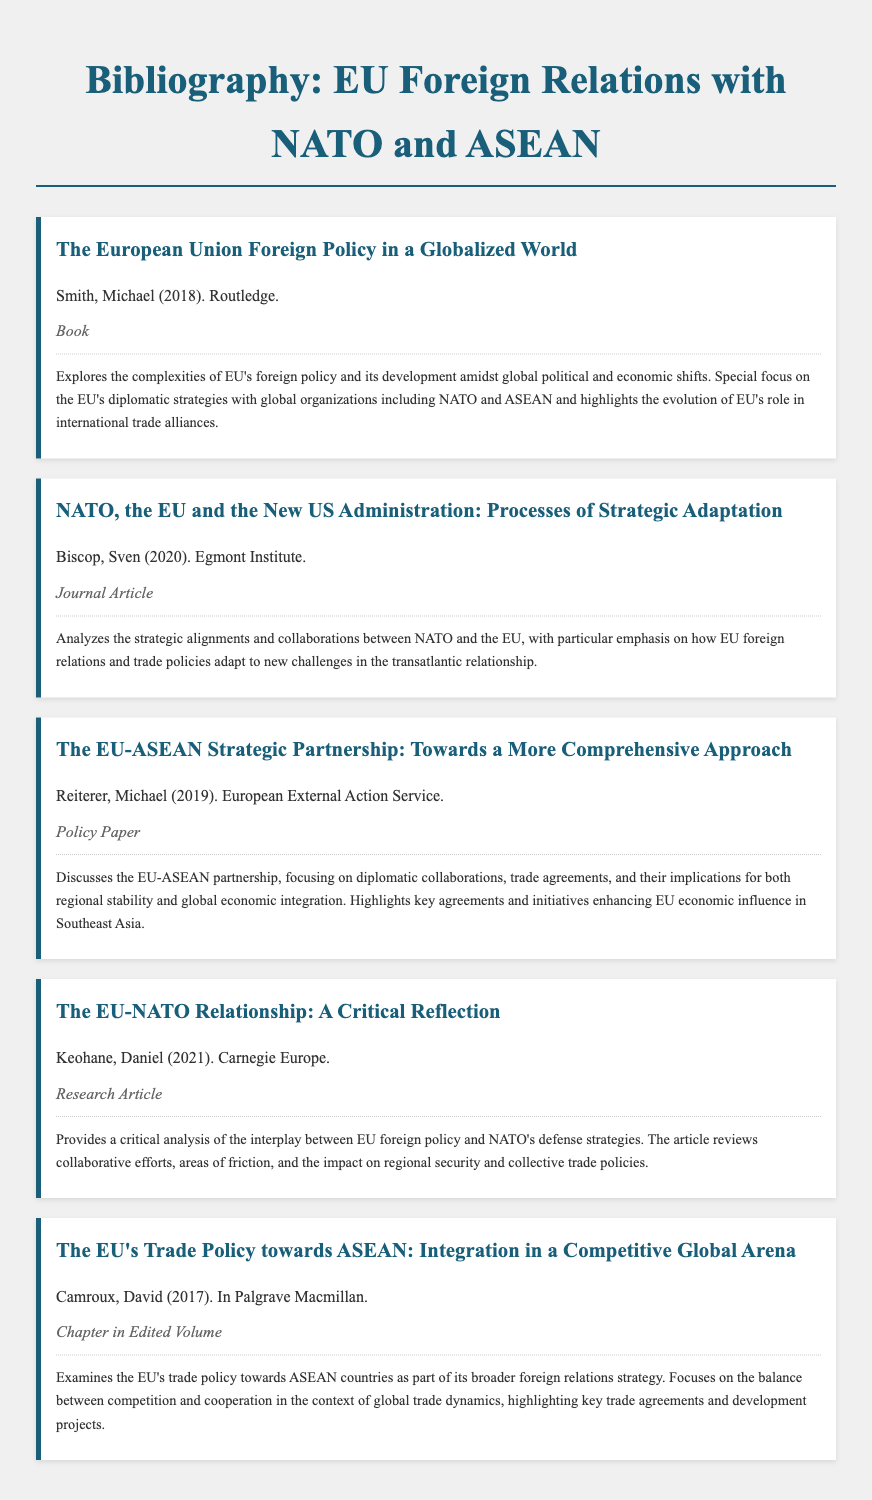What is the title of the book by Michael Smith? The title of the book is found in the first bibliography item.
Answer: The European Union Foreign Policy in a Globalized World Who authored the policy paper on the EU-ASEAN strategic partnership? The author's name is located in the third bibliography item.
Answer: Michael Reiterer In what year was the chapter on the EU's trade policy towards ASEAN published? The year of publication is specified in the fifth bibliography item.
Answer: 2017 What type of document is "The EU-NATO Relationship: A Critical Reflection"? The type of document is identified in the fourth bibliography item.
Answer: Research Article Which institute published the work by Sven Biscop? The publishing institute is noted in the second bibliography item.
Answer: Egmont Institute What is the main focus of Reiterer's policy paper? The main focus is summarized in the summary section of the third bibliography item.
Answer: Diplomatic collaborations and trade agreements How many bibliography items mention "trade agreements"? The count can be derived from the summaries of the relevant bibliography items.
Answer: 3 What is the color of the text in the bibliography items? The text color is specified in the style portion of the document and applies to all items.
Answer: #333 What year was the article by Daniel Keohane published? The publication year is indicated in the fourth bibliography item.
Answer: 2021 